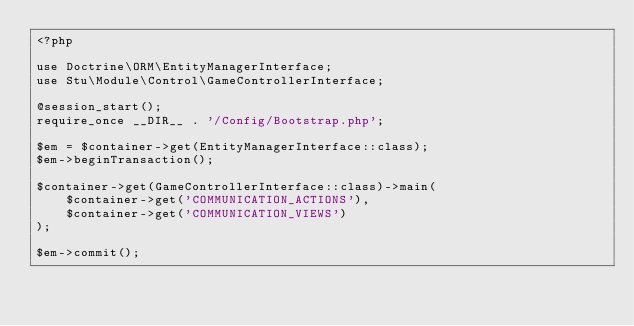<code> <loc_0><loc_0><loc_500><loc_500><_PHP_><?php

use Doctrine\ORM\EntityManagerInterface;
use Stu\Module\Control\GameControllerInterface;

@session_start();
require_once __DIR__ . '/Config/Bootstrap.php';

$em = $container->get(EntityManagerInterface::class);
$em->beginTransaction();

$container->get(GameControllerInterface::class)->main(
    $container->get('COMMUNICATION_ACTIONS'),
    $container->get('COMMUNICATION_VIEWS')
);

$em->commit();
</code> 